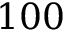Convert formula to latex. <formula><loc_0><loc_0><loc_500><loc_500>1 0 0</formula> 